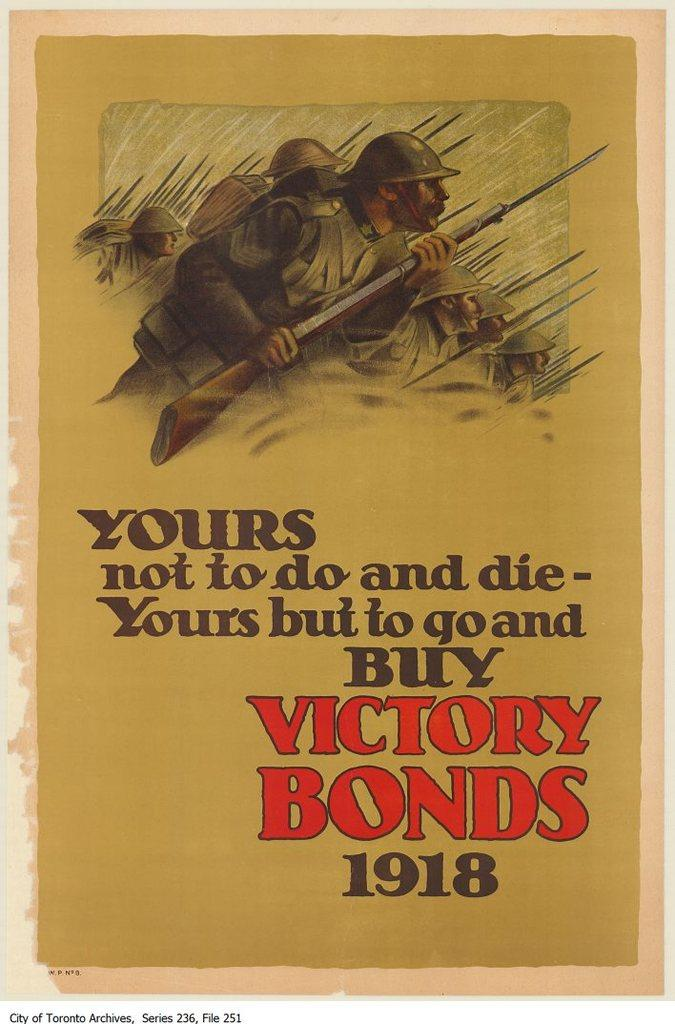<image>
Describe the image concisely. an ad with a solider at the top for victory bonds in 1918 